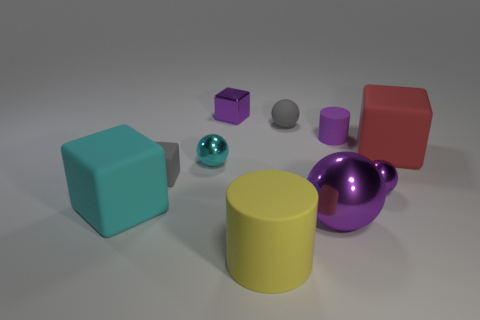What is the color of the other large sphere that is made of the same material as the cyan sphere?
Ensure brevity in your answer.  Purple. What is the color of the ball behind the big matte block right of the rubber ball on the right side of the yellow rubber cylinder?
Give a very brief answer. Gray. There is a red rubber cube; does it have the same size as the cyan object to the left of the tiny cyan metallic thing?
Provide a short and direct response. Yes. What number of objects are small balls left of the gray sphere or small purple objects behind the small cyan metallic thing?
Your answer should be compact. 3. What is the shape of the purple matte object that is the same size as the cyan metal sphere?
Make the answer very short. Cylinder. What shape is the large object behind the tiny purple thing that is in front of the cylinder behind the large red block?
Make the answer very short. Cube. Is the number of small gray spheres to the right of the big purple object the same as the number of tiny green metallic things?
Offer a very short reply. Yes. Do the red matte cube and the cyan rubber object have the same size?
Your answer should be very brief. Yes. What number of rubber things are tiny yellow balls or tiny gray things?
Offer a terse response. 2. What is the material of the purple sphere that is the same size as the red block?
Give a very brief answer. Metal. 